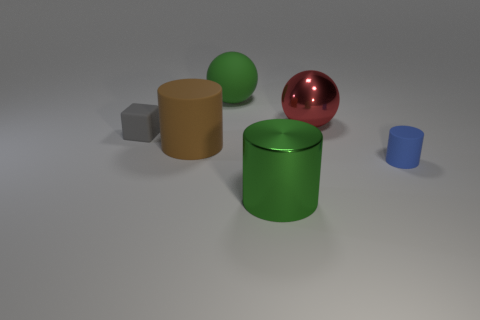Add 3 large balls. How many objects exist? 9 Subtract all cubes. How many objects are left? 5 Subtract all small blue shiny cubes. Subtract all tiny blue objects. How many objects are left? 5 Add 5 large green matte spheres. How many large green matte spheres are left? 6 Add 4 tiny cyan matte objects. How many tiny cyan matte objects exist? 4 Subtract 1 green cylinders. How many objects are left? 5 